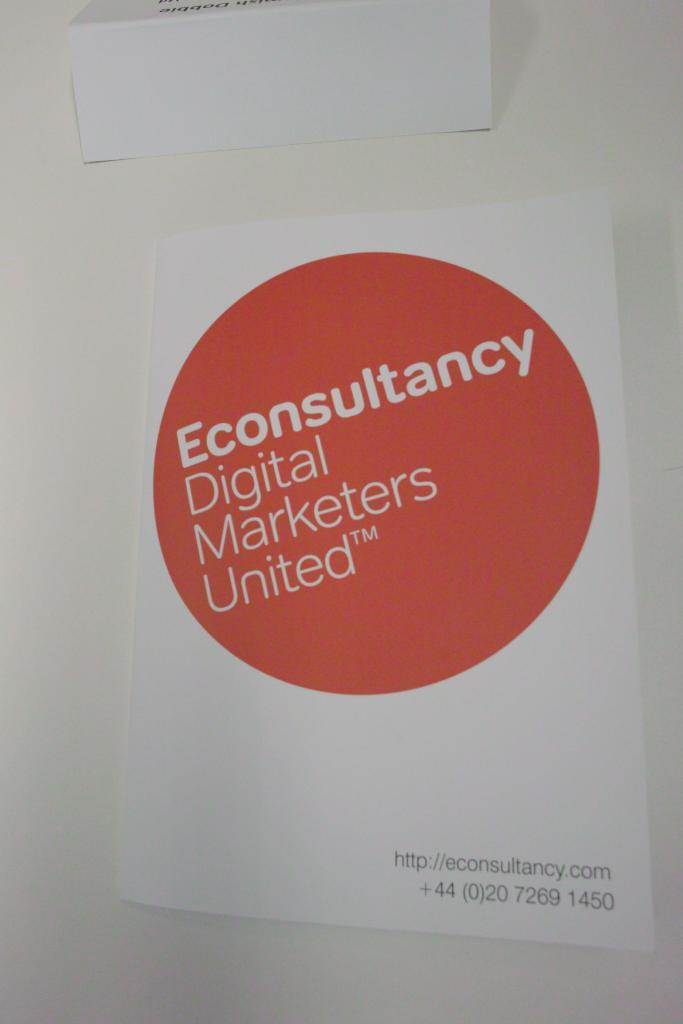What is the main subject in the middle of the image? There is a chart in the middle of the image with text written on it. What is located at the top of the image? There is a paper on the top of the image. What color is the background of the image? The background of the image is white. What type of sound can be heard coming from the chart in the image? There is no sound coming from the chart in the image, as it is a static visual representation. 